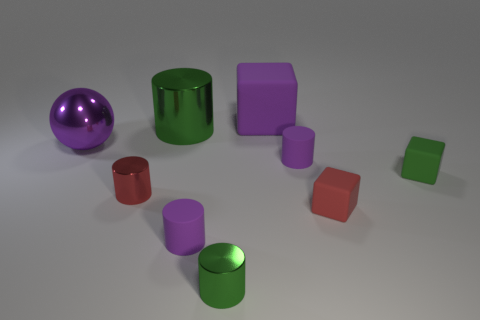Does the big sphere have the same color as the small cylinder on the right side of the big purple matte thing?
Ensure brevity in your answer.  Yes. There is a green cylinder that is in front of the large object to the left of the large green metal cylinder; what number of green cylinders are behind it?
Ensure brevity in your answer.  1. Are there any large objects behind the large green cylinder?
Your answer should be very brief. Yes. Is there anything else that has the same color as the metal ball?
Provide a short and direct response. Yes. How many cylinders are small purple matte objects or red things?
Provide a short and direct response. 3. What number of things are left of the red rubber cube and in front of the red shiny object?
Keep it short and to the point. 2. Are there the same number of big green objects on the left side of the big metallic sphere and things that are in front of the small green cylinder?
Provide a short and direct response. Yes. There is a green object that is right of the big matte cube; is its shape the same as the red metal object?
Give a very brief answer. No. What shape is the purple metal thing that is behind the matte cylinder that is behind the tiny green thing that is to the right of the red block?
Offer a terse response. Sphere. The large matte object that is the same color as the ball is what shape?
Ensure brevity in your answer.  Cube. 